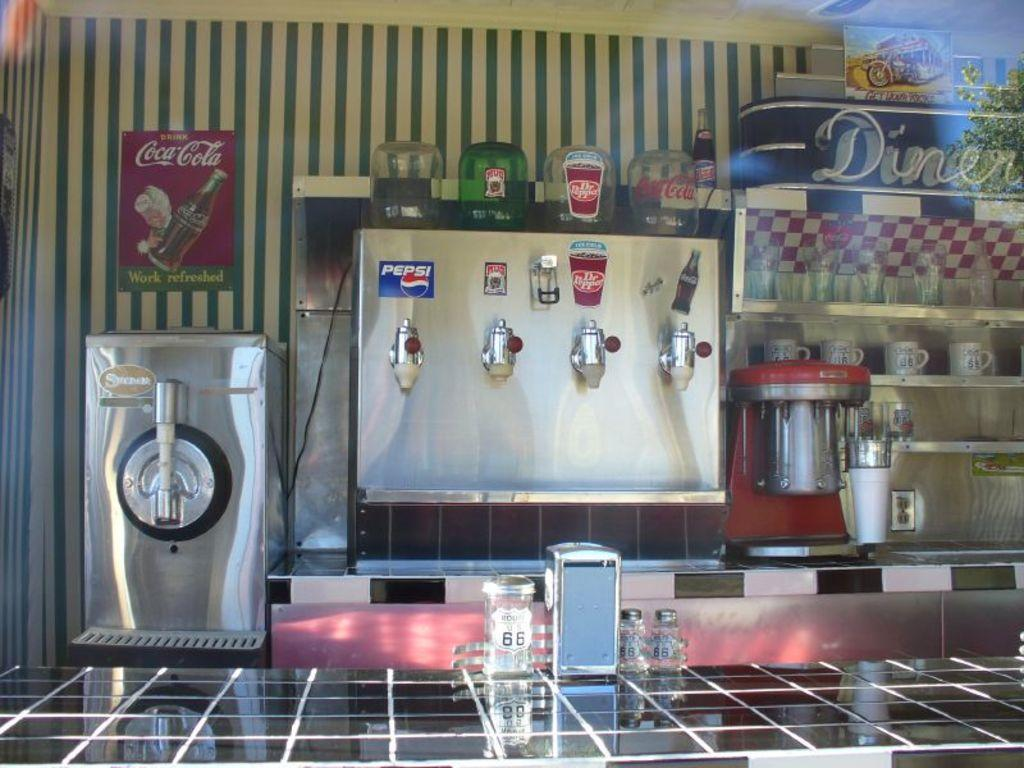<image>
Provide a brief description of the given image. A soda machine that has Dr. Pepper and Pepsi 